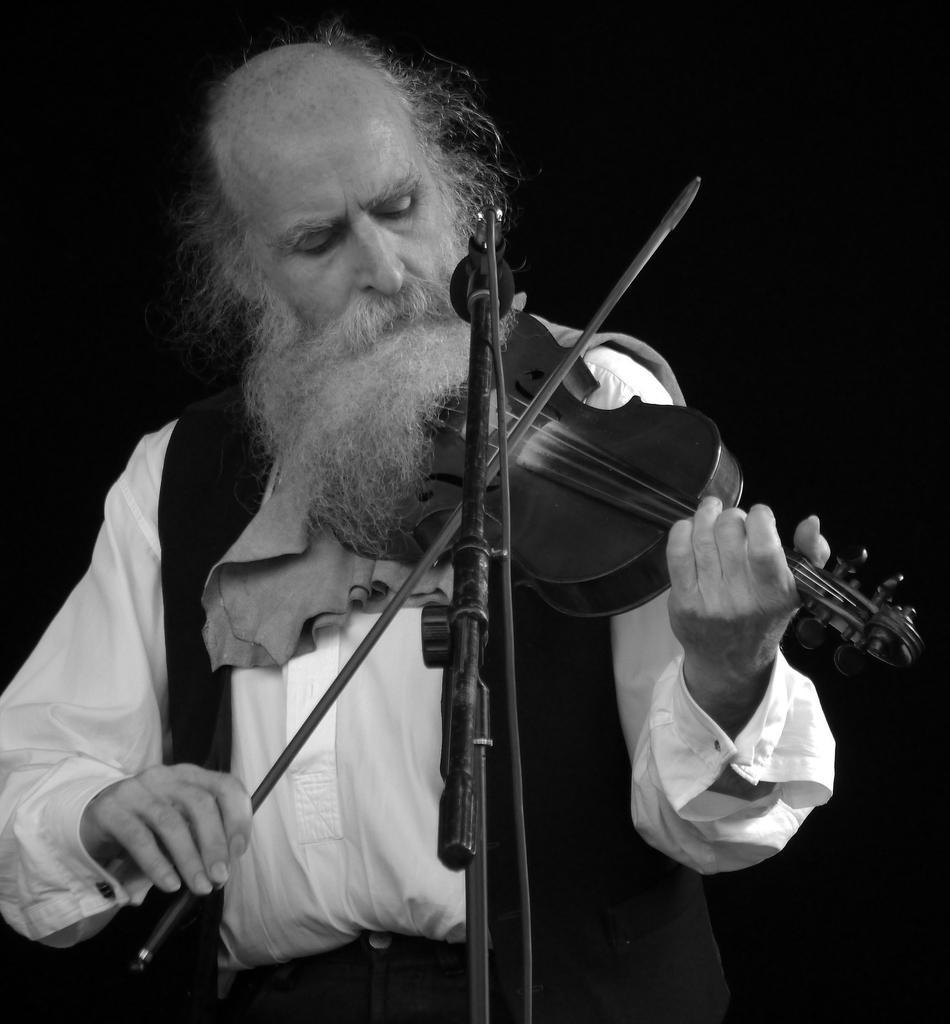How would you summarize this image in a sentence or two? This is of a black and white image. I can see a old man standing and playing violin. This is a mike with the mike stand. 